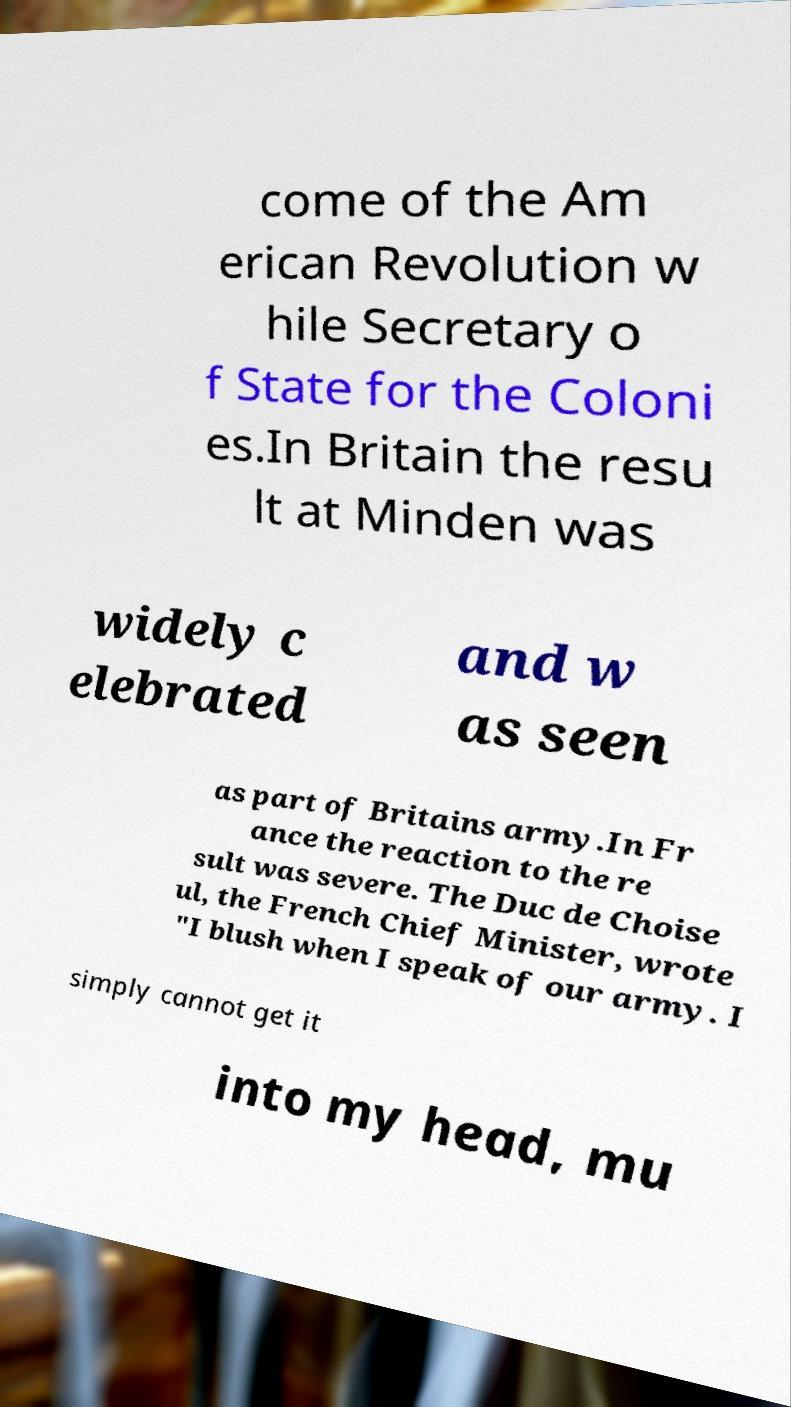What messages or text are displayed in this image? I need them in a readable, typed format. come of the Am erican Revolution w hile Secretary o f State for the Coloni es.In Britain the resu lt at Minden was widely c elebrated and w as seen as part of Britains army.In Fr ance the reaction to the re sult was severe. The Duc de Choise ul, the French Chief Minister, wrote "I blush when I speak of our army. I simply cannot get it into my head, mu 